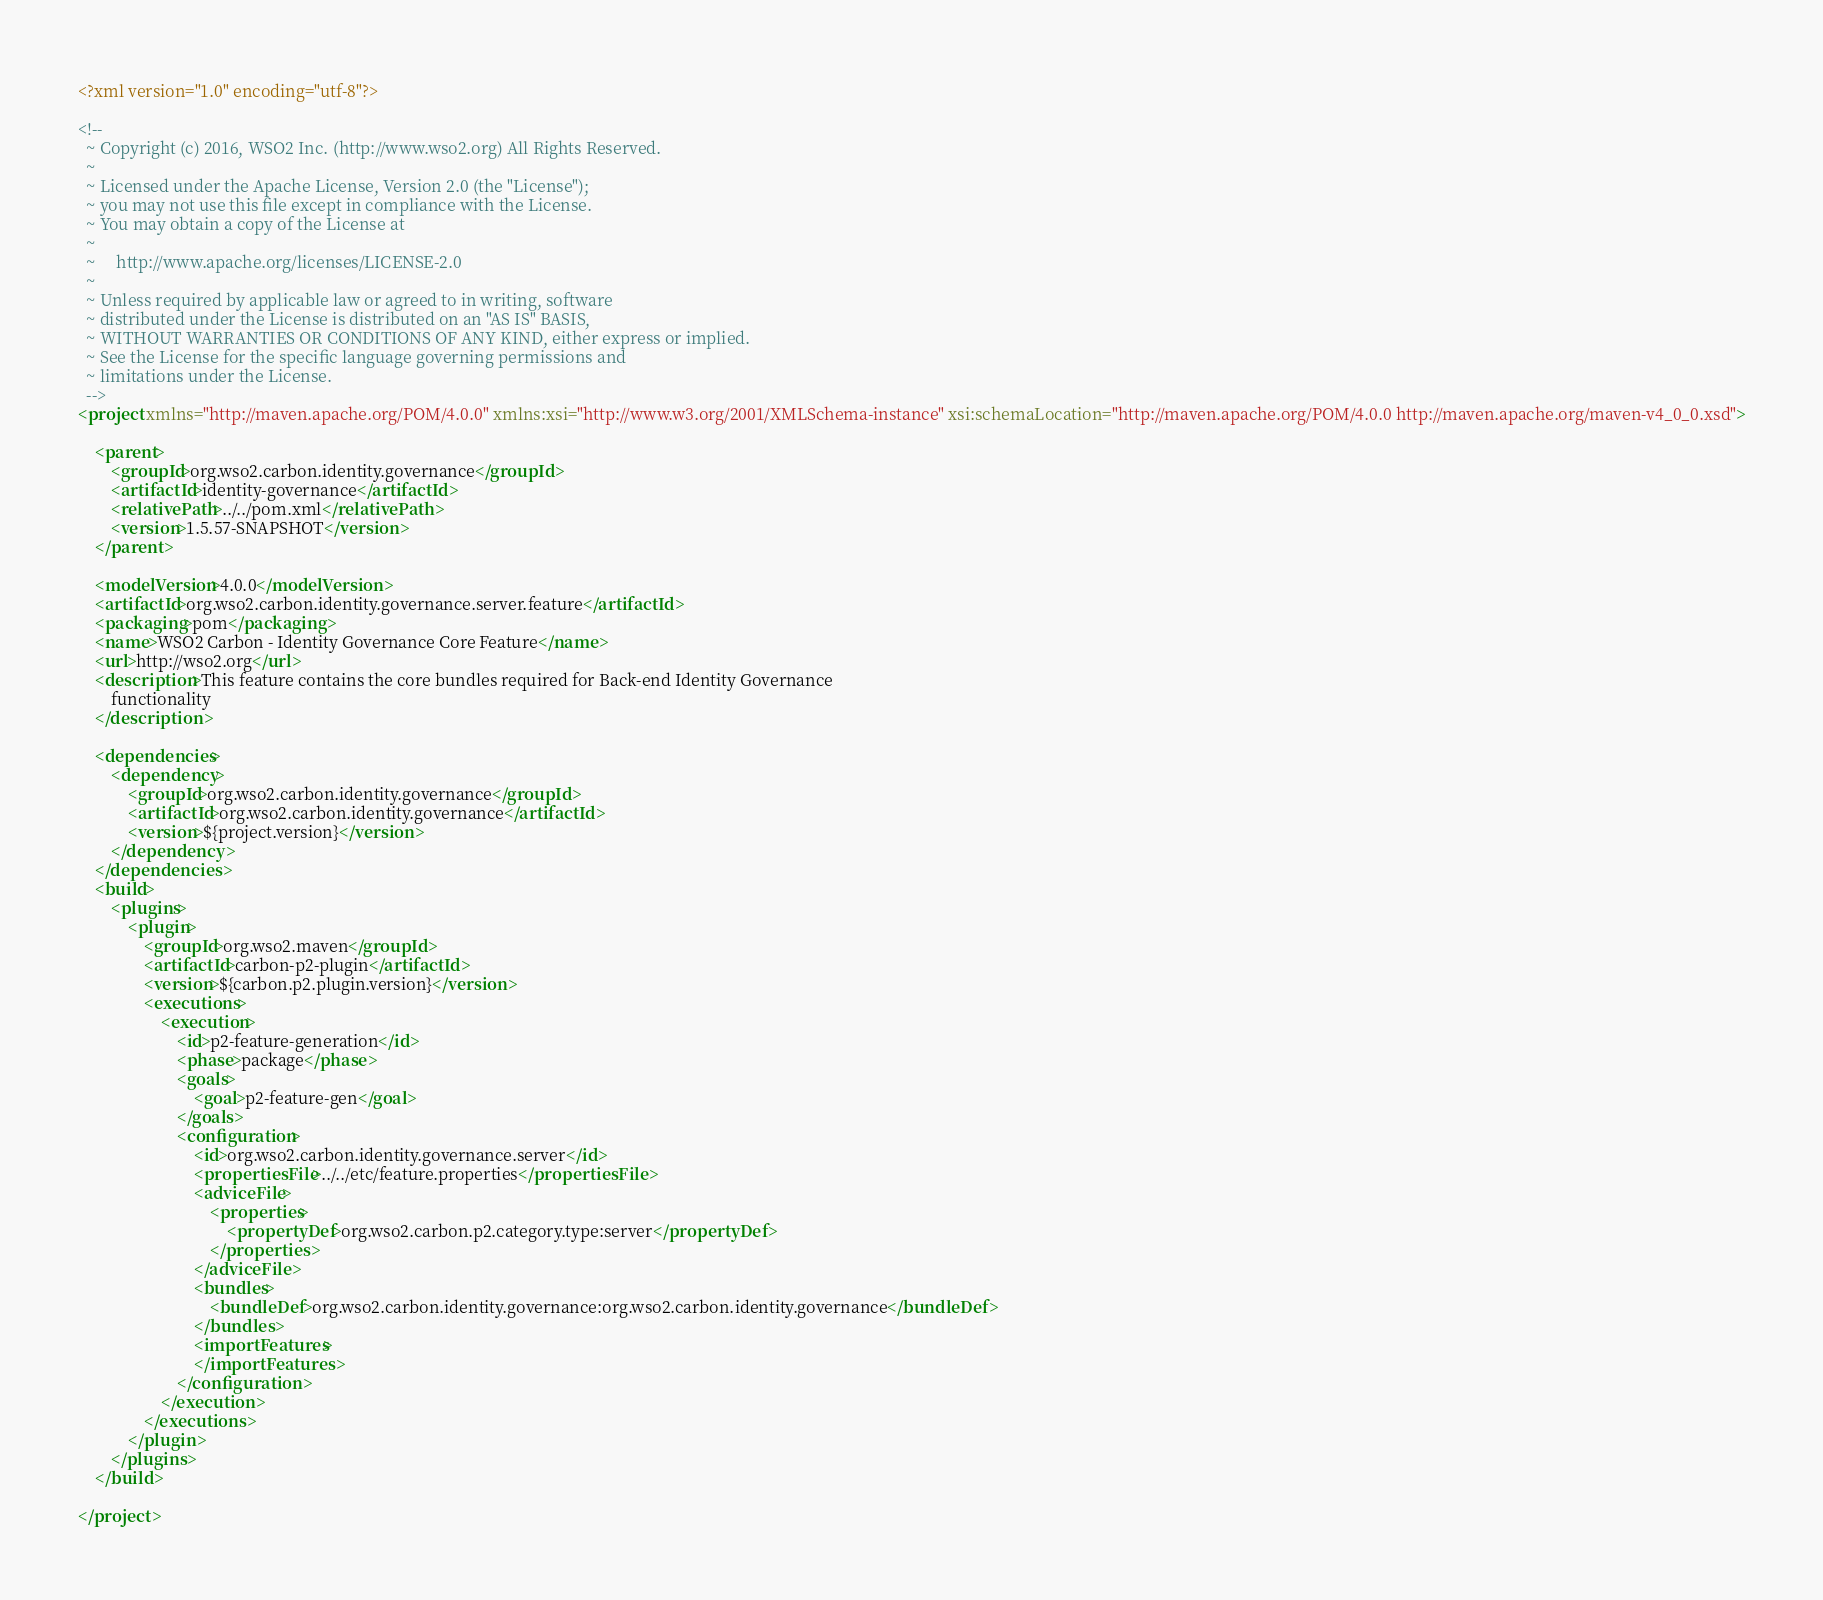<code> <loc_0><loc_0><loc_500><loc_500><_XML_><?xml version="1.0" encoding="utf-8"?>

<!--
  ~ Copyright (c) 2016, WSO2 Inc. (http://www.wso2.org) All Rights Reserved.
  ~
  ~ Licensed under the Apache License, Version 2.0 (the "License");
  ~ you may not use this file except in compliance with the License.
  ~ You may obtain a copy of the License at
  ~
  ~     http://www.apache.org/licenses/LICENSE-2.0
  ~
  ~ Unless required by applicable law or agreed to in writing, software
  ~ distributed under the License is distributed on an "AS IS" BASIS,
  ~ WITHOUT WARRANTIES OR CONDITIONS OF ANY KIND, either express or implied.
  ~ See the License for the specific language governing permissions and
  ~ limitations under the License.
  -->
<project xmlns="http://maven.apache.org/POM/4.0.0" xmlns:xsi="http://www.w3.org/2001/XMLSchema-instance" xsi:schemaLocation="http://maven.apache.org/POM/4.0.0 http://maven.apache.org/maven-v4_0_0.xsd">

    <parent>
        <groupId>org.wso2.carbon.identity.governance</groupId>
        <artifactId>identity-governance</artifactId>
        <relativePath>../../pom.xml</relativePath>
        <version>1.5.57-SNAPSHOT</version>
    </parent>

    <modelVersion>4.0.0</modelVersion>
    <artifactId>org.wso2.carbon.identity.governance.server.feature</artifactId>
    <packaging>pom</packaging>
    <name>WSO2 Carbon - Identity Governance Core Feature</name>
    <url>http://wso2.org</url>
    <description>This feature contains the core bundles required for Back-end Identity Governance
        functionality
    </description>

    <dependencies>
        <dependency>
            <groupId>org.wso2.carbon.identity.governance</groupId>
            <artifactId>org.wso2.carbon.identity.governance</artifactId>
            <version>${project.version}</version>
        </dependency>
    </dependencies>
    <build>
        <plugins>
            <plugin>
                <groupId>org.wso2.maven</groupId>
                <artifactId>carbon-p2-plugin</artifactId>
                <version>${carbon.p2.plugin.version}</version>
                <executions>
                    <execution>
                        <id>p2-feature-generation</id>
                        <phase>package</phase>
                        <goals>
                            <goal>p2-feature-gen</goal>
                        </goals>
                        <configuration>
                            <id>org.wso2.carbon.identity.governance.server</id>
                            <propertiesFile>../../etc/feature.properties</propertiesFile>
                            <adviceFile>
                                <properties>
                                    <propertyDef>org.wso2.carbon.p2.category.type:server</propertyDef>
                                </properties>
                            </adviceFile>
                            <bundles>
                                <bundleDef>org.wso2.carbon.identity.governance:org.wso2.carbon.identity.governance</bundleDef>
                            </bundles>
                            <importFeatures>
                            </importFeatures>
                        </configuration>
                    </execution>
                </executions>
            </plugin>
        </plugins>
    </build>

</project>
</code> 